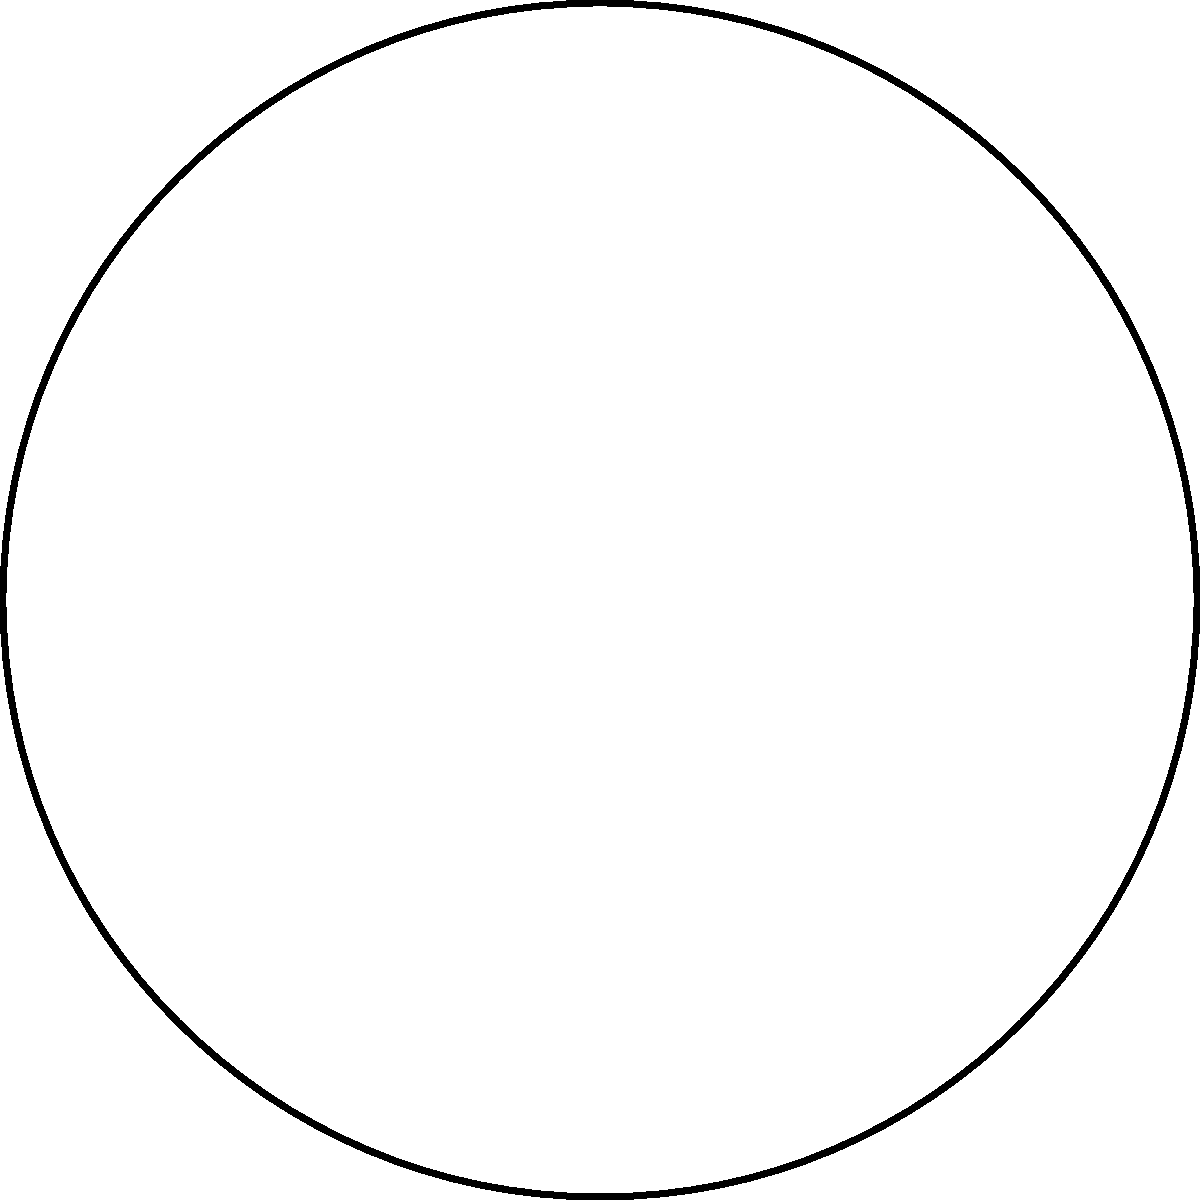Based on the technical drawing of a steampunk invention, which primary mechanical components are depicted, and what type of device is this likely to be? To classify this steampunk invention, let's analyze the components step-by-step:

1. Gears: The drawing shows two gears of different sizes. The larger gear is centrally positioned, while a smaller gear is to its right, meshing with the larger one. This gear system suggests a power transmission mechanism.

2. Piston: Below the gears, there's a rectangular shape with a connecting rod extending upwards. This is characteristic of a piston, which is typically used in engines to convert pressure into rotational motion.

3. Steam: Small curved lines above the smaller gear indicate the presence of steam or vapor, which is a hallmark of steampunk technology.

4. Arrangement: The piston is connected to the main gear, while the smaller gear and steam are positioned to interact with this system.

Given these components and their arrangement, we can deduce that this is likely a steam engine. The piston would convert the pressure from steam into linear motion, which is then transformed into rotational motion by the gear system. The smaller gear could be part of a governor or auxiliary system.

In steampunk context, this would be classified as a "Steam-Powered Rotary Engine" or simply a "Steampunk Engine."
Answer: Steam-Powered Rotary Engine 